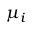<formula> <loc_0><loc_0><loc_500><loc_500>\mu _ { i }</formula> 